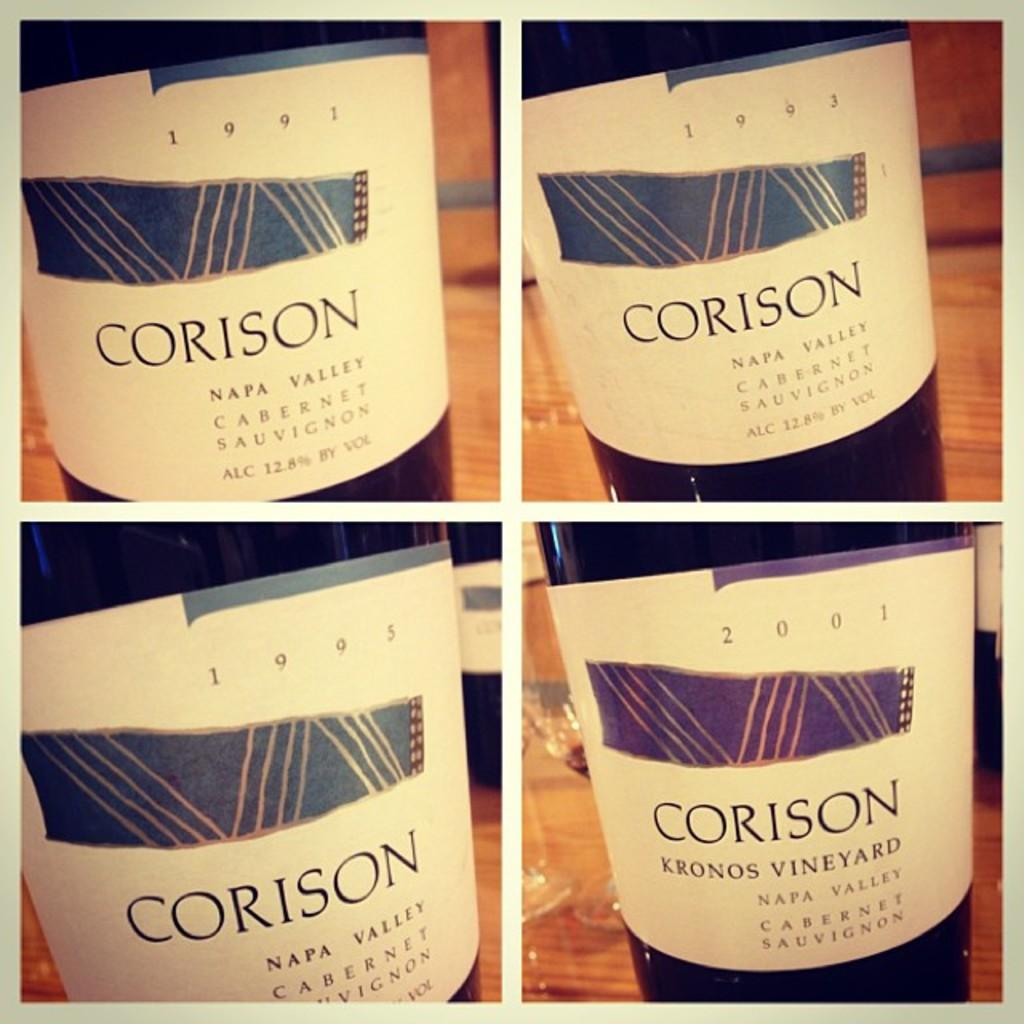Provide a one-sentence caption for the provided image. Four bottles of "CORISON" wine from Napa Valley are shown. 